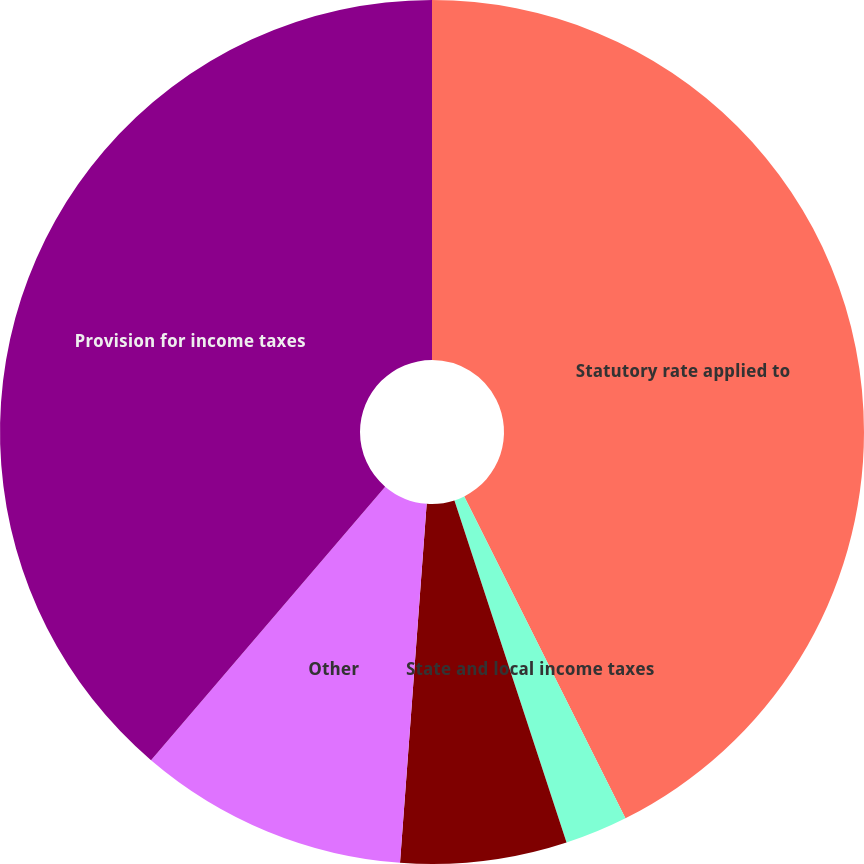Convert chart. <chart><loc_0><loc_0><loc_500><loc_500><pie_chart><fcel>Statutory rate applied to<fcel>State and local income taxes<fcel>Domestic manufacturing<fcel>Other<fcel>Provision for income taxes<nl><fcel>42.61%<fcel>2.35%<fcel>6.22%<fcel>10.09%<fcel>38.73%<nl></chart> 